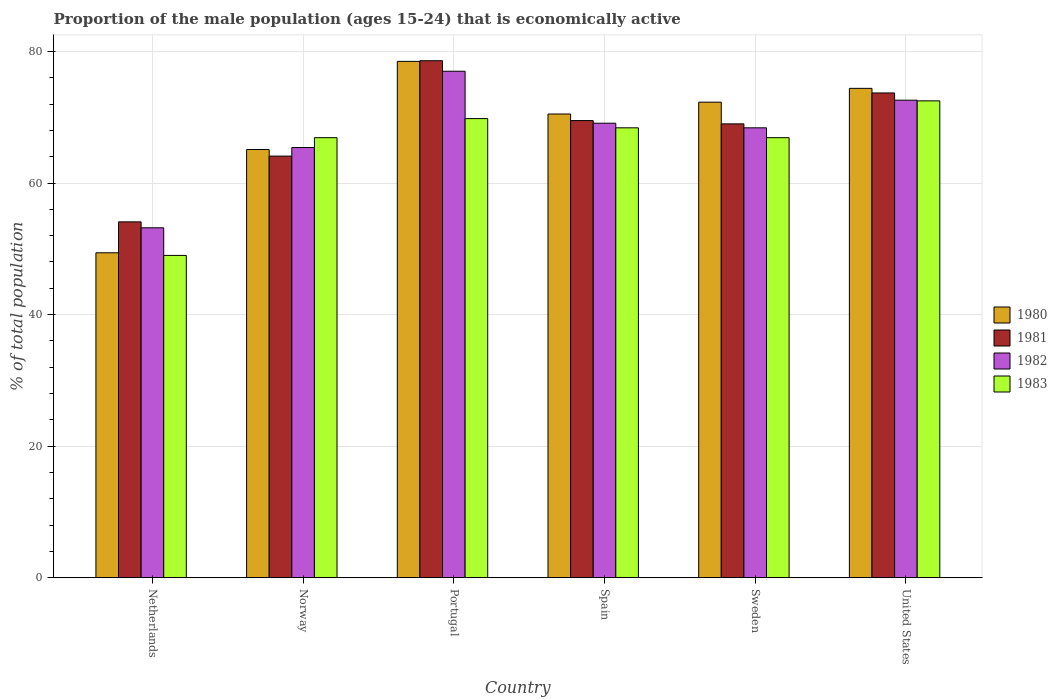How many groups of bars are there?
Keep it short and to the point. 6. Are the number of bars on each tick of the X-axis equal?
Offer a terse response. Yes. What is the label of the 1st group of bars from the left?
Your answer should be very brief. Netherlands. What is the proportion of the male population that is economically active in 1983 in Spain?
Ensure brevity in your answer.  68.4. Across all countries, what is the maximum proportion of the male population that is economically active in 1980?
Provide a succinct answer. 78.5. Across all countries, what is the minimum proportion of the male population that is economically active in 1982?
Offer a terse response. 53.2. In which country was the proportion of the male population that is economically active in 1981 maximum?
Make the answer very short. Portugal. In which country was the proportion of the male population that is economically active in 1983 minimum?
Your answer should be very brief. Netherlands. What is the total proportion of the male population that is economically active in 1981 in the graph?
Your response must be concise. 409. What is the difference between the proportion of the male population that is economically active in 1982 in Netherlands and that in Portugal?
Give a very brief answer. -23.8. What is the difference between the proportion of the male population that is economically active in 1982 in Sweden and the proportion of the male population that is economically active in 1983 in United States?
Ensure brevity in your answer.  -4.1. What is the average proportion of the male population that is economically active in 1983 per country?
Keep it short and to the point. 65.58. What is the difference between the proportion of the male population that is economically active of/in 1980 and proportion of the male population that is economically active of/in 1981 in Netherlands?
Offer a terse response. -4.7. What is the ratio of the proportion of the male population that is economically active in 1980 in Netherlands to that in Portugal?
Provide a short and direct response. 0.63. What is the difference between the highest and the second highest proportion of the male population that is economically active in 1981?
Offer a terse response. 4.2. What is the difference between the highest and the lowest proportion of the male population that is economically active in 1983?
Give a very brief answer. 23.5. What does the 3rd bar from the left in United States represents?
Give a very brief answer. 1982. Are all the bars in the graph horizontal?
Keep it short and to the point. No. What is the difference between two consecutive major ticks on the Y-axis?
Ensure brevity in your answer.  20. Are the values on the major ticks of Y-axis written in scientific E-notation?
Your response must be concise. No. Does the graph contain any zero values?
Your response must be concise. No. How are the legend labels stacked?
Your answer should be compact. Vertical. What is the title of the graph?
Your answer should be compact. Proportion of the male population (ages 15-24) that is economically active. What is the label or title of the X-axis?
Your response must be concise. Country. What is the label or title of the Y-axis?
Keep it short and to the point. % of total population. What is the % of total population of 1980 in Netherlands?
Keep it short and to the point. 49.4. What is the % of total population in 1981 in Netherlands?
Your answer should be compact. 54.1. What is the % of total population in 1982 in Netherlands?
Give a very brief answer. 53.2. What is the % of total population in 1980 in Norway?
Give a very brief answer. 65.1. What is the % of total population in 1981 in Norway?
Your answer should be compact. 64.1. What is the % of total population of 1982 in Norway?
Provide a succinct answer. 65.4. What is the % of total population of 1983 in Norway?
Give a very brief answer. 66.9. What is the % of total population of 1980 in Portugal?
Keep it short and to the point. 78.5. What is the % of total population in 1981 in Portugal?
Your response must be concise. 78.6. What is the % of total population of 1983 in Portugal?
Offer a terse response. 69.8. What is the % of total population of 1980 in Spain?
Your answer should be very brief. 70.5. What is the % of total population of 1981 in Spain?
Provide a short and direct response. 69.5. What is the % of total population in 1982 in Spain?
Your answer should be very brief. 69.1. What is the % of total population of 1983 in Spain?
Your answer should be very brief. 68.4. What is the % of total population of 1980 in Sweden?
Your response must be concise. 72.3. What is the % of total population in 1982 in Sweden?
Provide a succinct answer. 68.4. What is the % of total population of 1983 in Sweden?
Your response must be concise. 66.9. What is the % of total population in 1980 in United States?
Provide a short and direct response. 74.4. What is the % of total population of 1981 in United States?
Make the answer very short. 73.7. What is the % of total population in 1982 in United States?
Give a very brief answer. 72.6. What is the % of total population in 1983 in United States?
Offer a very short reply. 72.5. Across all countries, what is the maximum % of total population in 1980?
Provide a short and direct response. 78.5. Across all countries, what is the maximum % of total population in 1981?
Keep it short and to the point. 78.6. Across all countries, what is the maximum % of total population in 1983?
Your response must be concise. 72.5. Across all countries, what is the minimum % of total population of 1980?
Provide a succinct answer. 49.4. Across all countries, what is the minimum % of total population of 1981?
Your answer should be compact. 54.1. Across all countries, what is the minimum % of total population in 1982?
Your answer should be very brief. 53.2. What is the total % of total population in 1980 in the graph?
Keep it short and to the point. 410.2. What is the total % of total population in 1981 in the graph?
Your answer should be compact. 409. What is the total % of total population of 1982 in the graph?
Your response must be concise. 405.7. What is the total % of total population in 1983 in the graph?
Provide a short and direct response. 393.5. What is the difference between the % of total population in 1980 in Netherlands and that in Norway?
Provide a succinct answer. -15.7. What is the difference between the % of total population in 1983 in Netherlands and that in Norway?
Your answer should be very brief. -17.9. What is the difference between the % of total population of 1980 in Netherlands and that in Portugal?
Make the answer very short. -29.1. What is the difference between the % of total population in 1981 in Netherlands and that in Portugal?
Your answer should be very brief. -24.5. What is the difference between the % of total population in 1982 in Netherlands and that in Portugal?
Ensure brevity in your answer.  -23.8. What is the difference between the % of total population of 1983 in Netherlands and that in Portugal?
Give a very brief answer. -20.8. What is the difference between the % of total population of 1980 in Netherlands and that in Spain?
Offer a very short reply. -21.1. What is the difference between the % of total population of 1981 in Netherlands and that in Spain?
Keep it short and to the point. -15.4. What is the difference between the % of total population of 1982 in Netherlands and that in Spain?
Offer a terse response. -15.9. What is the difference between the % of total population of 1983 in Netherlands and that in Spain?
Your answer should be compact. -19.4. What is the difference between the % of total population in 1980 in Netherlands and that in Sweden?
Give a very brief answer. -22.9. What is the difference between the % of total population of 1981 in Netherlands and that in Sweden?
Give a very brief answer. -14.9. What is the difference between the % of total population in 1982 in Netherlands and that in Sweden?
Your answer should be very brief. -15.2. What is the difference between the % of total population in 1983 in Netherlands and that in Sweden?
Give a very brief answer. -17.9. What is the difference between the % of total population of 1980 in Netherlands and that in United States?
Make the answer very short. -25. What is the difference between the % of total population in 1981 in Netherlands and that in United States?
Give a very brief answer. -19.6. What is the difference between the % of total population in 1982 in Netherlands and that in United States?
Your response must be concise. -19.4. What is the difference between the % of total population in 1983 in Netherlands and that in United States?
Offer a terse response. -23.5. What is the difference between the % of total population in 1980 in Norway and that in Portugal?
Offer a terse response. -13.4. What is the difference between the % of total population in 1982 in Norway and that in Portugal?
Your answer should be compact. -11.6. What is the difference between the % of total population of 1983 in Norway and that in Portugal?
Make the answer very short. -2.9. What is the difference between the % of total population in 1983 in Norway and that in Spain?
Give a very brief answer. -1.5. What is the difference between the % of total population of 1980 in Norway and that in Sweden?
Your answer should be very brief. -7.2. What is the difference between the % of total population of 1982 in Norway and that in Sweden?
Your response must be concise. -3. What is the difference between the % of total population in 1983 in Norway and that in Sweden?
Make the answer very short. 0. What is the difference between the % of total population of 1982 in Norway and that in United States?
Provide a succinct answer. -7.2. What is the difference between the % of total population of 1980 in Portugal and that in Spain?
Give a very brief answer. 8. What is the difference between the % of total population of 1981 in Portugal and that in Spain?
Your answer should be compact. 9.1. What is the difference between the % of total population of 1983 in Portugal and that in Spain?
Give a very brief answer. 1.4. What is the difference between the % of total population in 1980 in Portugal and that in Sweden?
Ensure brevity in your answer.  6.2. What is the difference between the % of total population in 1981 in Portugal and that in Sweden?
Your answer should be compact. 9.6. What is the difference between the % of total population of 1983 in Portugal and that in Sweden?
Provide a short and direct response. 2.9. What is the difference between the % of total population in 1982 in Portugal and that in United States?
Keep it short and to the point. 4.4. What is the difference between the % of total population in 1980 in Spain and that in Sweden?
Offer a terse response. -1.8. What is the difference between the % of total population in 1982 in Spain and that in Sweden?
Offer a very short reply. 0.7. What is the difference between the % of total population in 1981 in Spain and that in United States?
Your answer should be compact. -4.2. What is the difference between the % of total population of 1983 in Spain and that in United States?
Ensure brevity in your answer.  -4.1. What is the difference between the % of total population in 1980 in Sweden and that in United States?
Your answer should be very brief. -2.1. What is the difference between the % of total population in 1983 in Sweden and that in United States?
Your answer should be very brief. -5.6. What is the difference between the % of total population of 1980 in Netherlands and the % of total population of 1981 in Norway?
Provide a short and direct response. -14.7. What is the difference between the % of total population in 1980 in Netherlands and the % of total population in 1983 in Norway?
Keep it short and to the point. -17.5. What is the difference between the % of total population of 1981 in Netherlands and the % of total population of 1982 in Norway?
Provide a short and direct response. -11.3. What is the difference between the % of total population in 1981 in Netherlands and the % of total population in 1983 in Norway?
Give a very brief answer. -12.8. What is the difference between the % of total population of 1982 in Netherlands and the % of total population of 1983 in Norway?
Offer a terse response. -13.7. What is the difference between the % of total population in 1980 in Netherlands and the % of total population in 1981 in Portugal?
Your answer should be compact. -29.2. What is the difference between the % of total population in 1980 in Netherlands and the % of total population in 1982 in Portugal?
Make the answer very short. -27.6. What is the difference between the % of total population in 1980 in Netherlands and the % of total population in 1983 in Portugal?
Make the answer very short. -20.4. What is the difference between the % of total population of 1981 in Netherlands and the % of total population of 1982 in Portugal?
Give a very brief answer. -22.9. What is the difference between the % of total population of 1981 in Netherlands and the % of total population of 1983 in Portugal?
Provide a short and direct response. -15.7. What is the difference between the % of total population of 1982 in Netherlands and the % of total population of 1983 in Portugal?
Make the answer very short. -16.6. What is the difference between the % of total population of 1980 in Netherlands and the % of total population of 1981 in Spain?
Keep it short and to the point. -20.1. What is the difference between the % of total population in 1980 in Netherlands and the % of total population in 1982 in Spain?
Give a very brief answer. -19.7. What is the difference between the % of total population of 1981 in Netherlands and the % of total population of 1983 in Spain?
Your answer should be very brief. -14.3. What is the difference between the % of total population in 1982 in Netherlands and the % of total population in 1983 in Spain?
Make the answer very short. -15.2. What is the difference between the % of total population of 1980 in Netherlands and the % of total population of 1981 in Sweden?
Make the answer very short. -19.6. What is the difference between the % of total population in 1980 in Netherlands and the % of total population in 1983 in Sweden?
Your response must be concise. -17.5. What is the difference between the % of total population in 1981 in Netherlands and the % of total population in 1982 in Sweden?
Ensure brevity in your answer.  -14.3. What is the difference between the % of total population of 1982 in Netherlands and the % of total population of 1983 in Sweden?
Ensure brevity in your answer.  -13.7. What is the difference between the % of total population in 1980 in Netherlands and the % of total population in 1981 in United States?
Your response must be concise. -24.3. What is the difference between the % of total population of 1980 in Netherlands and the % of total population of 1982 in United States?
Keep it short and to the point. -23.2. What is the difference between the % of total population in 1980 in Netherlands and the % of total population in 1983 in United States?
Provide a short and direct response. -23.1. What is the difference between the % of total population in 1981 in Netherlands and the % of total population in 1982 in United States?
Provide a short and direct response. -18.5. What is the difference between the % of total population in 1981 in Netherlands and the % of total population in 1983 in United States?
Your answer should be compact. -18.4. What is the difference between the % of total population of 1982 in Netherlands and the % of total population of 1983 in United States?
Your answer should be very brief. -19.3. What is the difference between the % of total population in 1980 in Norway and the % of total population in 1981 in Portugal?
Offer a very short reply. -13.5. What is the difference between the % of total population in 1980 in Norway and the % of total population in 1981 in Spain?
Give a very brief answer. -4.4. What is the difference between the % of total population in 1981 in Norway and the % of total population in 1982 in Spain?
Give a very brief answer. -5. What is the difference between the % of total population in 1981 in Norway and the % of total population in 1983 in Spain?
Offer a very short reply. -4.3. What is the difference between the % of total population in 1982 in Norway and the % of total population in 1983 in Spain?
Offer a terse response. -3. What is the difference between the % of total population in 1980 in Norway and the % of total population in 1981 in Sweden?
Your answer should be very brief. -3.9. What is the difference between the % of total population of 1980 in Norway and the % of total population of 1982 in Sweden?
Keep it short and to the point. -3.3. What is the difference between the % of total population in 1980 in Norway and the % of total population in 1983 in Sweden?
Make the answer very short. -1.8. What is the difference between the % of total population of 1981 in Norway and the % of total population of 1982 in Sweden?
Your answer should be very brief. -4.3. What is the difference between the % of total population of 1980 in Norway and the % of total population of 1982 in United States?
Make the answer very short. -7.5. What is the difference between the % of total population of 1980 in Norway and the % of total population of 1983 in United States?
Your answer should be very brief. -7.4. What is the difference between the % of total population of 1981 in Norway and the % of total population of 1982 in United States?
Offer a very short reply. -8.5. What is the difference between the % of total population of 1981 in Norway and the % of total population of 1983 in United States?
Make the answer very short. -8.4. What is the difference between the % of total population of 1982 in Norway and the % of total population of 1983 in United States?
Provide a succinct answer. -7.1. What is the difference between the % of total population in 1980 in Portugal and the % of total population in 1981 in Spain?
Ensure brevity in your answer.  9. What is the difference between the % of total population in 1980 in Portugal and the % of total population in 1982 in Spain?
Your answer should be compact. 9.4. What is the difference between the % of total population in 1981 in Portugal and the % of total population in 1982 in Spain?
Keep it short and to the point. 9.5. What is the difference between the % of total population of 1981 in Portugal and the % of total population of 1983 in Spain?
Offer a very short reply. 10.2. What is the difference between the % of total population of 1980 in Portugal and the % of total population of 1983 in Sweden?
Keep it short and to the point. 11.6. What is the difference between the % of total population of 1980 in Portugal and the % of total population of 1982 in United States?
Your answer should be compact. 5.9. What is the difference between the % of total population in 1980 in Spain and the % of total population in 1981 in Sweden?
Provide a short and direct response. 1.5. What is the difference between the % of total population of 1980 in Spain and the % of total population of 1982 in Sweden?
Your answer should be very brief. 2.1. What is the difference between the % of total population of 1980 in Spain and the % of total population of 1983 in Sweden?
Your answer should be very brief. 3.6. What is the difference between the % of total population of 1981 in Spain and the % of total population of 1982 in Sweden?
Offer a terse response. 1.1. What is the difference between the % of total population of 1982 in Spain and the % of total population of 1983 in Sweden?
Give a very brief answer. 2.2. What is the difference between the % of total population of 1980 in Spain and the % of total population of 1982 in United States?
Offer a very short reply. -2.1. What is the difference between the % of total population of 1980 in Spain and the % of total population of 1983 in United States?
Give a very brief answer. -2. What is the difference between the % of total population in 1981 in Spain and the % of total population in 1983 in United States?
Make the answer very short. -3. What is the difference between the % of total population in 1982 in Spain and the % of total population in 1983 in United States?
Provide a succinct answer. -3.4. What is the difference between the % of total population in 1980 in Sweden and the % of total population in 1981 in United States?
Provide a short and direct response. -1.4. What is the difference between the % of total population of 1980 in Sweden and the % of total population of 1983 in United States?
Keep it short and to the point. -0.2. What is the average % of total population in 1980 per country?
Offer a very short reply. 68.37. What is the average % of total population in 1981 per country?
Provide a succinct answer. 68.17. What is the average % of total population in 1982 per country?
Provide a succinct answer. 67.62. What is the average % of total population in 1983 per country?
Your answer should be very brief. 65.58. What is the difference between the % of total population of 1980 and % of total population of 1983 in Netherlands?
Give a very brief answer. 0.4. What is the difference between the % of total population in 1982 and % of total population in 1983 in Netherlands?
Your answer should be compact. 4.2. What is the difference between the % of total population in 1980 and % of total population in 1981 in Norway?
Give a very brief answer. 1. What is the difference between the % of total population of 1980 and % of total population of 1983 in Norway?
Your answer should be very brief. -1.8. What is the difference between the % of total population in 1981 and % of total population in 1982 in Norway?
Provide a succinct answer. -1.3. What is the difference between the % of total population in 1981 and % of total population in 1983 in Norway?
Make the answer very short. -2.8. What is the difference between the % of total population of 1982 and % of total population of 1983 in Norway?
Ensure brevity in your answer.  -1.5. What is the difference between the % of total population of 1980 and % of total population of 1981 in Portugal?
Offer a terse response. -0.1. What is the difference between the % of total population of 1981 and % of total population of 1982 in Portugal?
Give a very brief answer. 1.6. What is the difference between the % of total population in 1981 and % of total population in 1983 in Portugal?
Keep it short and to the point. 8.8. What is the difference between the % of total population of 1982 and % of total population of 1983 in Portugal?
Keep it short and to the point. 7.2. What is the difference between the % of total population in 1980 and % of total population in 1982 in Spain?
Give a very brief answer. 1.4. What is the difference between the % of total population in 1980 and % of total population in 1983 in Spain?
Your answer should be compact. 2.1. What is the difference between the % of total population in 1981 and % of total population in 1983 in Spain?
Keep it short and to the point. 1.1. What is the difference between the % of total population in 1980 and % of total population in 1981 in Sweden?
Give a very brief answer. 3.3. What is the difference between the % of total population in 1980 and % of total population in 1983 in Sweden?
Provide a succinct answer. 5.4. What is the difference between the % of total population in 1981 and % of total population in 1982 in Sweden?
Your answer should be compact. 0.6. What is the difference between the % of total population in 1982 and % of total population in 1983 in Sweden?
Provide a short and direct response. 1.5. What is the difference between the % of total population in 1982 and % of total population in 1983 in United States?
Keep it short and to the point. 0.1. What is the ratio of the % of total population in 1980 in Netherlands to that in Norway?
Offer a very short reply. 0.76. What is the ratio of the % of total population in 1981 in Netherlands to that in Norway?
Offer a very short reply. 0.84. What is the ratio of the % of total population in 1982 in Netherlands to that in Norway?
Make the answer very short. 0.81. What is the ratio of the % of total population in 1983 in Netherlands to that in Norway?
Make the answer very short. 0.73. What is the ratio of the % of total population in 1980 in Netherlands to that in Portugal?
Keep it short and to the point. 0.63. What is the ratio of the % of total population of 1981 in Netherlands to that in Portugal?
Keep it short and to the point. 0.69. What is the ratio of the % of total population of 1982 in Netherlands to that in Portugal?
Your answer should be compact. 0.69. What is the ratio of the % of total population in 1983 in Netherlands to that in Portugal?
Your answer should be compact. 0.7. What is the ratio of the % of total population of 1980 in Netherlands to that in Spain?
Your response must be concise. 0.7. What is the ratio of the % of total population in 1981 in Netherlands to that in Spain?
Provide a succinct answer. 0.78. What is the ratio of the % of total population in 1982 in Netherlands to that in Spain?
Keep it short and to the point. 0.77. What is the ratio of the % of total population of 1983 in Netherlands to that in Spain?
Keep it short and to the point. 0.72. What is the ratio of the % of total population of 1980 in Netherlands to that in Sweden?
Make the answer very short. 0.68. What is the ratio of the % of total population in 1981 in Netherlands to that in Sweden?
Provide a succinct answer. 0.78. What is the ratio of the % of total population in 1983 in Netherlands to that in Sweden?
Make the answer very short. 0.73. What is the ratio of the % of total population of 1980 in Netherlands to that in United States?
Your answer should be compact. 0.66. What is the ratio of the % of total population of 1981 in Netherlands to that in United States?
Your answer should be very brief. 0.73. What is the ratio of the % of total population in 1982 in Netherlands to that in United States?
Make the answer very short. 0.73. What is the ratio of the % of total population in 1983 in Netherlands to that in United States?
Your answer should be very brief. 0.68. What is the ratio of the % of total population in 1980 in Norway to that in Portugal?
Give a very brief answer. 0.83. What is the ratio of the % of total population of 1981 in Norway to that in Portugal?
Give a very brief answer. 0.82. What is the ratio of the % of total population of 1982 in Norway to that in Portugal?
Your answer should be compact. 0.85. What is the ratio of the % of total population in 1983 in Norway to that in Portugal?
Keep it short and to the point. 0.96. What is the ratio of the % of total population in 1980 in Norway to that in Spain?
Your response must be concise. 0.92. What is the ratio of the % of total population of 1981 in Norway to that in Spain?
Your answer should be compact. 0.92. What is the ratio of the % of total population of 1982 in Norway to that in Spain?
Provide a short and direct response. 0.95. What is the ratio of the % of total population in 1983 in Norway to that in Spain?
Provide a short and direct response. 0.98. What is the ratio of the % of total population in 1980 in Norway to that in Sweden?
Make the answer very short. 0.9. What is the ratio of the % of total population in 1981 in Norway to that in Sweden?
Offer a very short reply. 0.93. What is the ratio of the % of total population of 1982 in Norway to that in Sweden?
Make the answer very short. 0.96. What is the ratio of the % of total population of 1980 in Norway to that in United States?
Keep it short and to the point. 0.88. What is the ratio of the % of total population in 1981 in Norway to that in United States?
Give a very brief answer. 0.87. What is the ratio of the % of total population in 1982 in Norway to that in United States?
Make the answer very short. 0.9. What is the ratio of the % of total population in 1983 in Norway to that in United States?
Your answer should be very brief. 0.92. What is the ratio of the % of total population of 1980 in Portugal to that in Spain?
Your answer should be very brief. 1.11. What is the ratio of the % of total population in 1981 in Portugal to that in Spain?
Your answer should be very brief. 1.13. What is the ratio of the % of total population in 1982 in Portugal to that in Spain?
Provide a succinct answer. 1.11. What is the ratio of the % of total population in 1983 in Portugal to that in Spain?
Offer a very short reply. 1.02. What is the ratio of the % of total population of 1980 in Portugal to that in Sweden?
Ensure brevity in your answer.  1.09. What is the ratio of the % of total population in 1981 in Portugal to that in Sweden?
Ensure brevity in your answer.  1.14. What is the ratio of the % of total population of 1982 in Portugal to that in Sweden?
Your response must be concise. 1.13. What is the ratio of the % of total population of 1983 in Portugal to that in Sweden?
Offer a very short reply. 1.04. What is the ratio of the % of total population of 1980 in Portugal to that in United States?
Provide a succinct answer. 1.06. What is the ratio of the % of total population in 1981 in Portugal to that in United States?
Your response must be concise. 1.07. What is the ratio of the % of total population of 1982 in Portugal to that in United States?
Offer a very short reply. 1.06. What is the ratio of the % of total population in 1983 in Portugal to that in United States?
Keep it short and to the point. 0.96. What is the ratio of the % of total population of 1980 in Spain to that in Sweden?
Give a very brief answer. 0.98. What is the ratio of the % of total population of 1981 in Spain to that in Sweden?
Offer a very short reply. 1.01. What is the ratio of the % of total population in 1982 in Spain to that in Sweden?
Ensure brevity in your answer.  1.01. What is the ratio of the % of total population of 1983 in Spain to that in Sweden?
Offer a very short reply. 1.02. What is the ratio of the % of total population of 1980 in Spain to that in United States?
Offer a terse response. 0.95. What is the ratio of the % of total population of 1981 in Spain to that in United States?
Provide a short and direct response. 0.94. What is the ratio of the % of total population of 1982 in Spain to that in United States?
Provide a short and direct response. 0.95. What is the ratio of the % of total population in 1983 in Spain to that in United States?
Offer a very short reply. 0.94. What is the ratio of the % of total population in 1980 in Sweden to that in United States?
Keep it short and to the point. 0.97. What is the ratio of the % of total population of 1981 in Sweden to that in United States?
Offer a terse response. 0.94. What is the ratio of the % of total population of 1982 in Sweden to that in United States?
Ensure brevity in your answer.  0.94. What is the ratio of the % of total population of 1983 in Sweden to that in United States?
Provide a succinct answer. 0.92. What is the difference between the highest and the second highest % of total population in 1980?
Provide a short and direct response. 4.1. What is the difference between the highest and the second highest % of total population of 1981?
Keep it short and to the point. 4.9. What is the difference between the highest and the lowest % of total population of 1980?
Offer a very short reply. 29.1. What is the difference between the highest and the lowest % of total population of 1982?
Your answer should be compact. 23.8. 